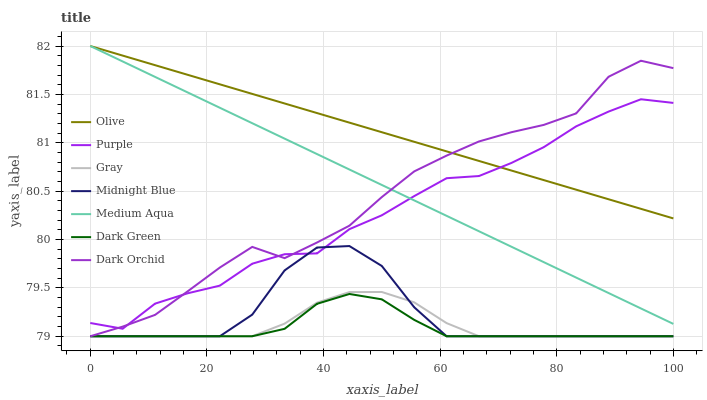Does Dark Green have the minimum area under the curve?
Answer yes or no. Yes. Does Olive have the maximum area under the curve?
Answer yes or no. Yes. Does Midnight Blue have the minimum area under the curve?
Answer yes or no. No. Does Midnight Blue have the maximum area under the curve?
Answer yes or no. No. Is Olive the smoothest?
Answer yes or no. Yes. Is Dark Orchid the roughest?
Answer yes or no. Yes. Is Midnight Blue the smoothest?
Answer yes or no. No. Is Midnight Blue the roughest?
Answer yes or no. No. Does Gray have the lowest value?
Answer yes or no. Yes. Does Purple have the lowest value?
Answer yes or no. No. Does Olive have the highest value?
Answer yes or no. Yes. Does Midnight Blue have the highest value?
Answer yes or no. No. Is Midnight Blue less than Olive?
Answer yes or no. Yes. Is Olive greater than Midnight Blue?
Answer yes or no. Yes. Does Purple intersect Dark Orchid?
Answer yes or no. Yes. Is Purple less than Dark Orchid?
Answer yes or no. No. Is Purple greater than Dark Orchid?
Answer yes or no. No. Does Midnight Blue intersect Olive?
Answer yes or no. No. 